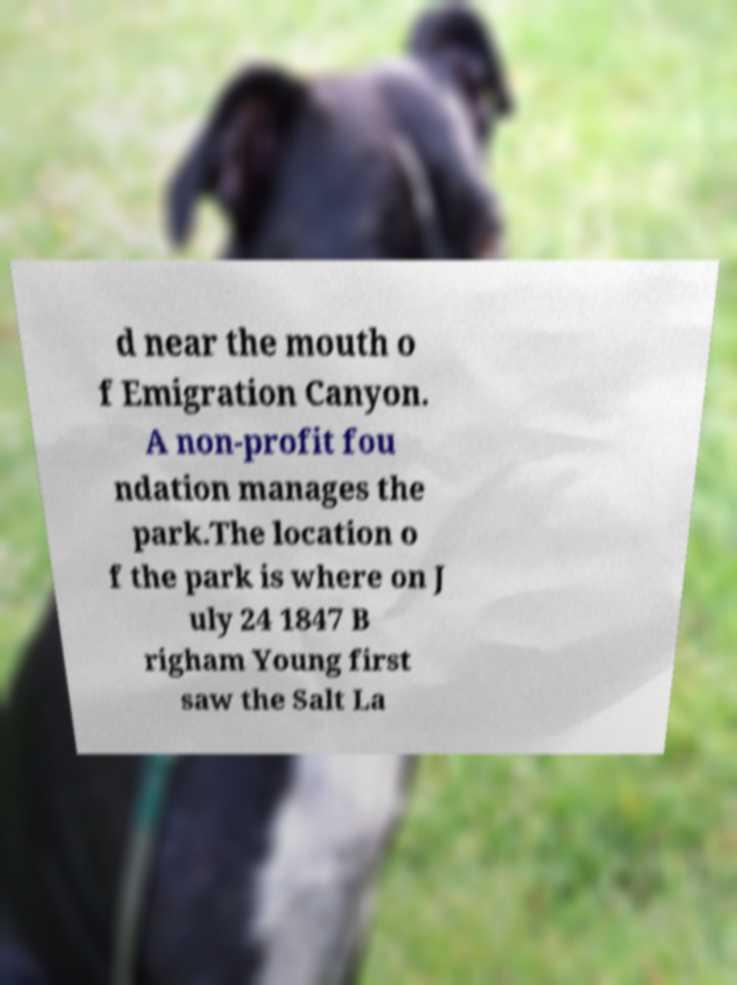Please identify and transcribe the text found in this image. d near the mouth o f Emigration Canyon. A non-profit fou ndation manages the park.The location o f the park is where on J uly 24 1847 B righam Young first saw the Salt La 